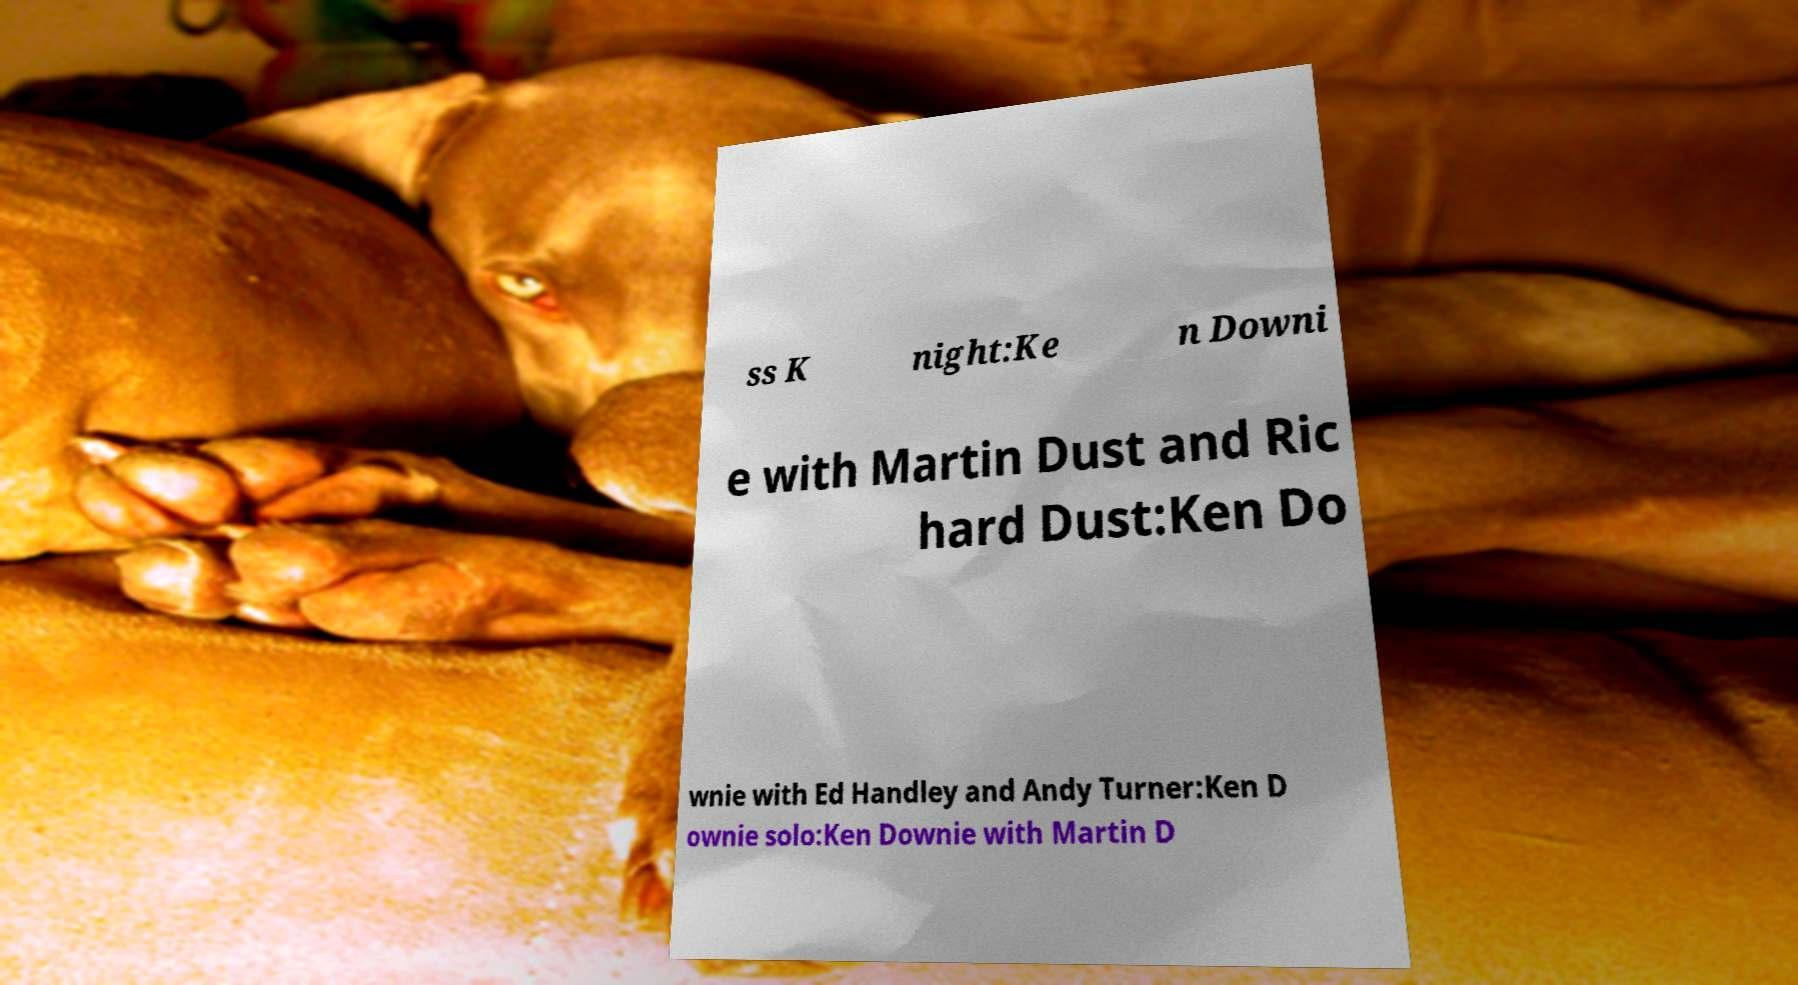Please identify and transcribe the text found in this image. ss K night:Ke n Downi e with Martin Dust and Ric hard Dust:Ken Do wnie with Ed Handley and Andy Turner:Ken D ownie solo:Ken Downie with Martin D 